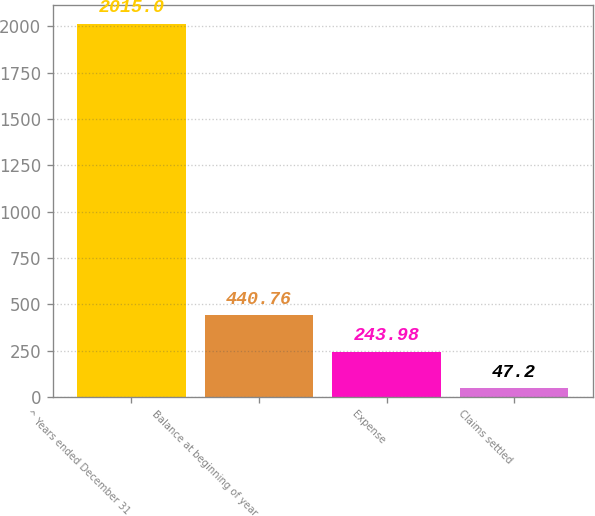Convert chart to OTSL. <chart><loc_0><loc_0><loc_500><loc_500><bar_chart><fcel>^ Years ended December 31<fcel>Balance at beginning of year<fcel>Expense<fcel>Claims settled<nl><fcel>2015<fcel>440.76<fcel>243.98<fcel>47.2<nl></chart> 